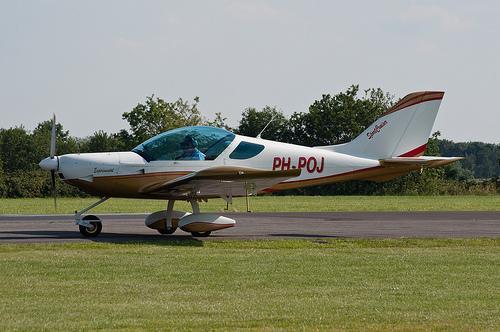How many planes are there?
Give a very brief answer. 1. 